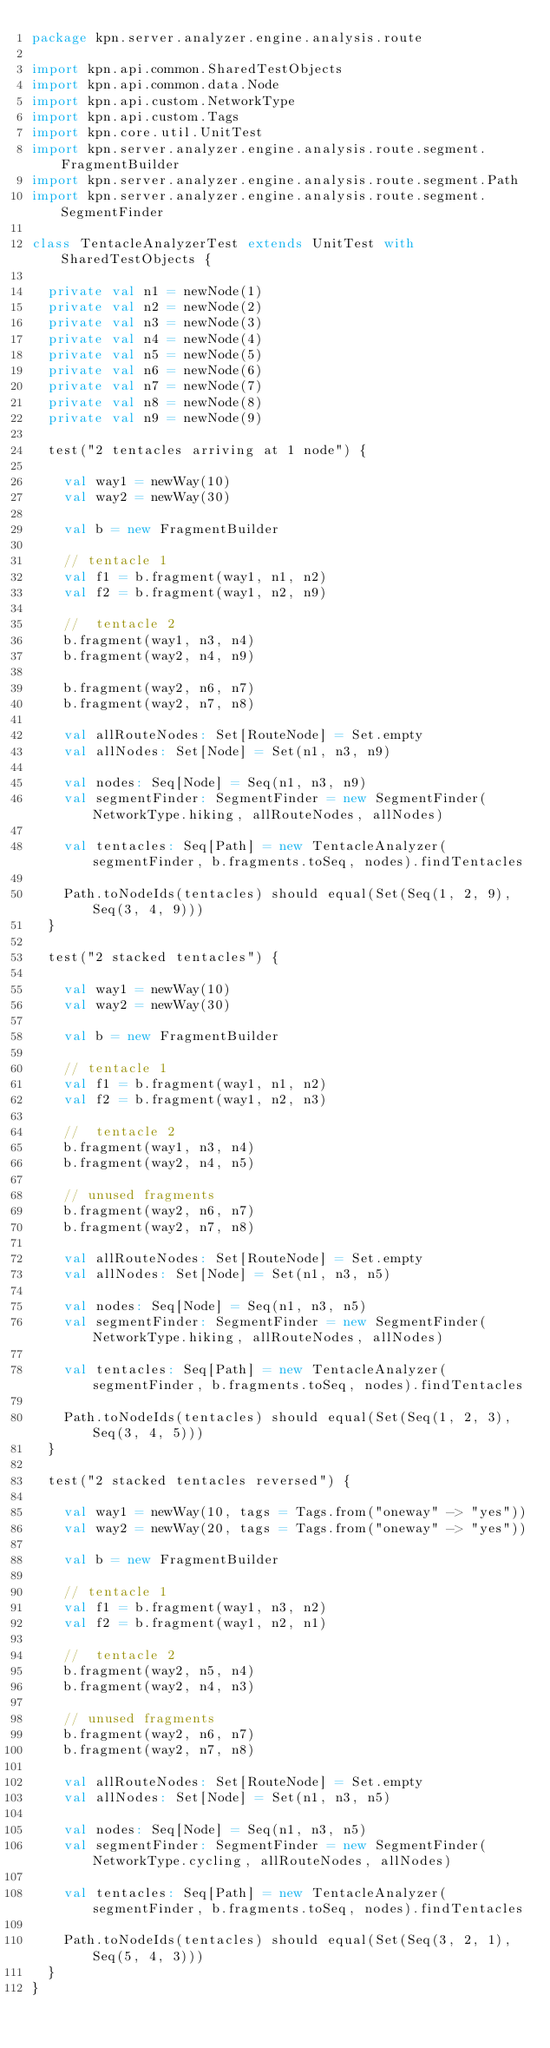Convert code to text. <code><loc_0><loc_0><loc_500><loc_500><_Scala_>package kpn.server.analyzer.engine.analysis.route

import kpn.api.common.SharedTestObjects
import kpn.api.common.data.Node
import kpn.api.custom.NetworkType
import kpn.api.custom.Tags
import kpn.core.util.UnitTest
import kpn.server.analyzer.engine.analysis.route.segment.FragmentBuilder
import kpn.server.analyzer.engine.analysis.route.segment.Path
import kpn.server.analyzer.engine.analysis.route.segment.SegmentFinder

class TentacleAnalyzerTest extends UnitTest with SharedTestObjects {

  private val n1 = newNode(1)
  private val n2 = newNode(2)
  private val n3 = newNode(3)
  private val n4 = newNode(4)
  private val n5 = newNode(5)
  private val n6 = newNode(6)
  private val n7 = newNode(7)
  private val n8 = newNode(8)
  private val n9 = newNode(9)

  test("2 tentacles arriving at 1 node") {

    val way1 = newWay(10)
    val way2 = newWay(30)

    val b = new FragmentBuilder

    // tentacle 1
    val f1 = b.fragment(way1, n1, n2)
    val f2 = b.fragment(way1, n2, n9)

    //  tentacle 2
    b.fragment(way1, n3, n4)
    b.fragment(way2, n4, n9)

    b.fragment(way2, n6, n7)
    b.fragment(way2, n7, n8)

    val allRouteNodes: Set[RouteNode] = Set.empty
    val allNodes: Set[Node] = Set(n1, n3, n9)

    val nodes: Seq[Node] = Seq(n1, n3, n9)
    val segmentFinder: SegmentFinder = new SegmentFinder(NetworkType.hiking, allRouteNodes, allNodes)

    val tentacles: Seq[Path] = new TentacleAnalyzer(segmentFinder, b.fragments.toSeq, nodes).findTentacles

    Path.toNodeIds(tentacles) should equal(Set(Seq(1, 2, 9), Seq(3, 4, 9)))
  }

  test("2 stacked tentacles") {

    val way1 = newWay(10)
    val way2 = newWay(30)

    val b = new FragmentBuilder

    // tentacle 1
    val f1 = b.fragment(way1, n1, n2)
    val f2 = b.fragment(way1, n2, n3)

    //  tentacle 2
    b.fragment(way1, n3, n4)
    b.fragment(way2, n4, n5)

    // unused fragments
    b.fragment(way2, n6, n7)
    b.fragment(way2, n7, n8)

    val allRouteNodes: Set[RouteNode] = Set.empty
    val allNodes: Set[Node] = Set(n1, n3, n5)

    val nodes: Seq[Node] = Seq(n1, n3, n5)
    val segmentFinder: SegmentFinder = new SegmentFinder(NetworkType.hiking, allRouteNodes, allNodes)

    val tentacles: Seq[Path] = new TentacleAnalyzer(segmentFinder, b.fragments.toSeq, nodes).findTentacles

    Path.toNodeIds(tentacles) should equal(Set(Seq(1, 2, 3), Seq(3, 4, 5)))
  }

  test("2 stacked tentacles reversed") {

    val way1 = newWay(10, tags = Tags.from("oneway" -> "yes"))
    val way2 = newWay(20, tags = Tags.from("oneway" -> "yes"))

    val b = new FragmentBuilder

    // tentacle 1
    val f1 = b.fragment(way1, n3, n2)
    val f2 = b.fragment(way1, n2, n1)

    //  tentacle 2
    b.fragment(way2, n5, n4)
    b.fragment(way2, n4, n3)

    // unused fragments
    b.fragment(way2, n6, n7)
    b.fragment(way2, n7, n8)

    val allRouteNodes: Set[RouteNode] = Set.empty
    val allNodes: Set[Node] = Set(n1, n3, n5)

    val nodes: Seq[Node] = Seq(n1, n3, n5)
    val segmentFinder: SegmentFinder = new SegmentFinder(NetworkType.cycling, allRouteNodes, allNodes)

    val tentacles: Seq[Path] = new TentacleAnalyzer(segmentFinder, b.fragments.toSeq, nodes).findTentacles

    Path.toNodeIds(tentacles) should equal(Set(Seq(3, 2, 1), Seq(5, 4, 3)))
  }
}
</code> 